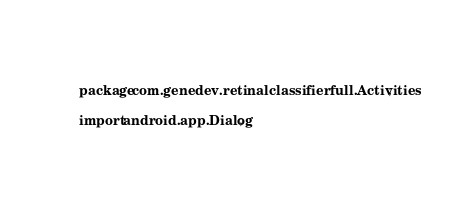Convert code to text. <code><loc_0><loc_0><loc_500><loc_500><_Java_>package com.genedev.retinalclassifierfull.Activities;

import android.app.Dialog;</code> 